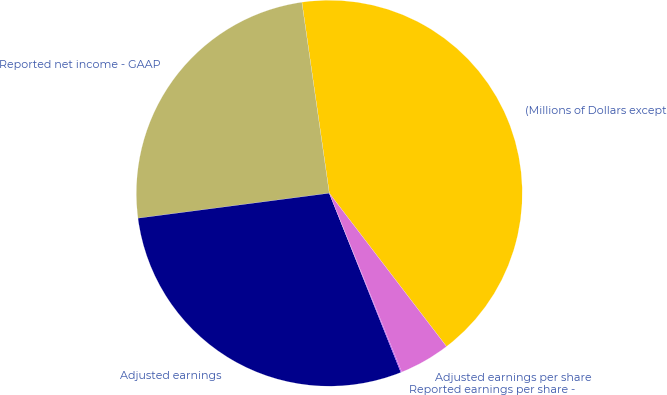Convert chart. <chart><loc_0><loc_0><loc_500><loc_500><pie_chart><fcel>(Millions of Dollars except<fcel>Reported net income - GAAP<fcel>Adjusted earnings<fcel>Reported earnings per share -<fcel>Adjusted earnings per share<nl><fcel>41.88%<fcel>24.8%<fcel>28.98%<fcel>0.08%<fcel>4.26%<nl></chart> 